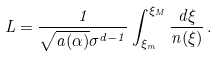<formula> <loc_0><loc_0><loc_500><loc_500>L = \frac { 1 } { \sqrt { a ( \alpha ) } \sigma ^ { d - 1 } } \int _ { \xi _ { m } } ^ { \xi _ { M } } \frac { d \xi } { n ( \xi ) } \, .</formula> 